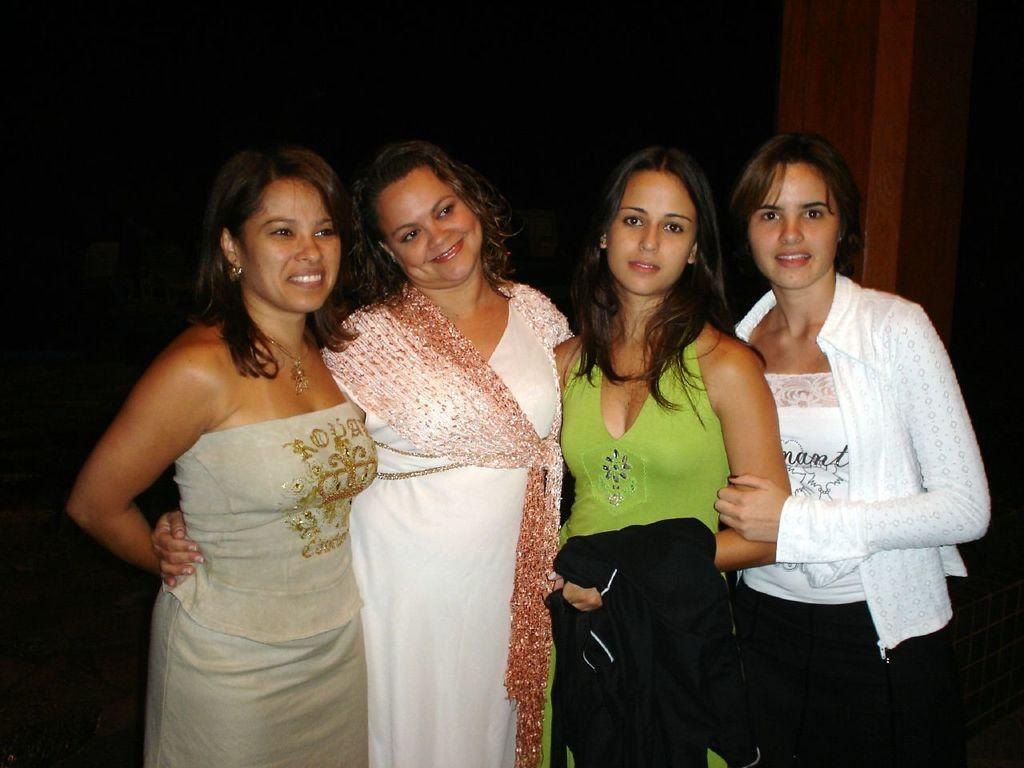What are the people in the image doing? The people in the image are posing for a photo. Can you describe the background of the image? The background of the image is dark. What type of volleyball is being used by the people in the image? There is no volleyball present in the image; the people are posing for a photo. What kind of breakfast is being served on the throne in the image? There is no throne or breakfast present in the image. 